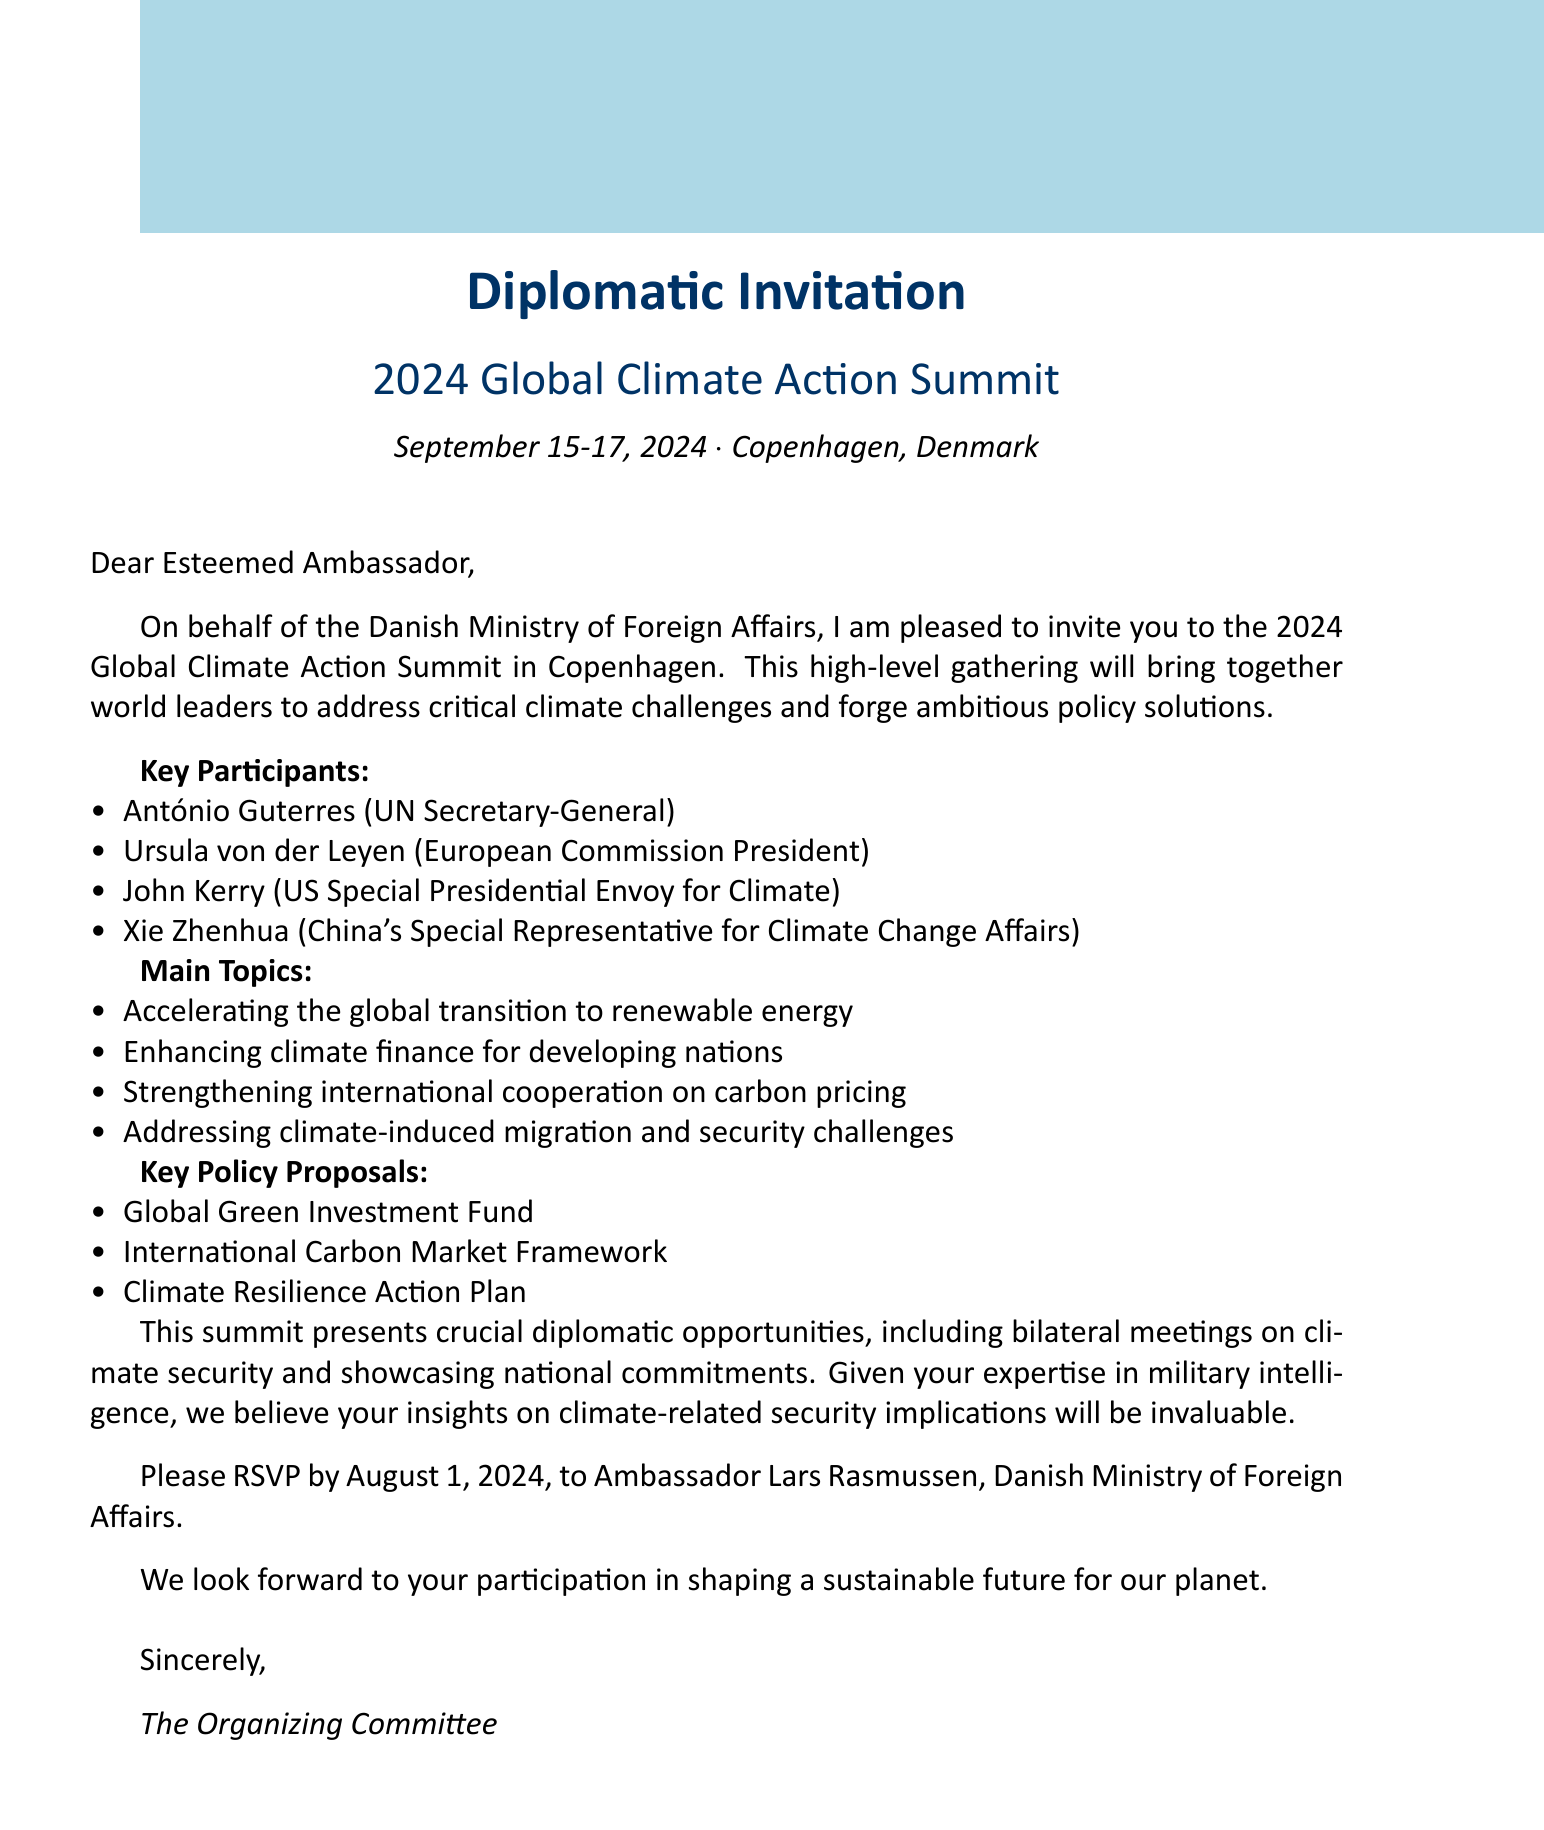What is the name of the summit? The name of the summit is stated clearly in the document as "2024 Global Climate Action Summit."
Answer: 2024 Global Climate Action Summit Who is the host country of the summit? The document specifies that the host country for the summit is Denmark.
Answer: Denmark What are the dates of the summit? The invitation provides the specific dates for the summit, which are September 15-17, 2024.
Answer: September 15-17, 2024 Who should RSVP to the invitation? The document indicates that responses should be directed to Ambassador Lars Rasmussen.
Answer: Ambassador Lars Rasmussen What is one of the main topics to be discussed at the summit? The document lists several main topics, one of which is "Accelerating the global transition to renewable energy."
Answer: Accelerating the global transition to renewable energy How many key participants are listed in the document? The document includes four key participants who will be attending the summit.
Answer: Four What is the RSVP deadline for the summit? The document specifies that the RSVP deadline is August 1, 2024.
Answer: August 1, 2024 What military intelligence relevance is mentioned in the invitation? The document states multiple relevance points; one key aspect is "Potential security implications of climate-induced resource scarcity."
Answer: Potential security implications of climate-induced resource scarcity What opportunity does the summit provide related to climate security? The document mentions opportunities such as "Bilateral meetings with key allies on climate security."
Answer: Bilateral meetings with key allies on climate security 